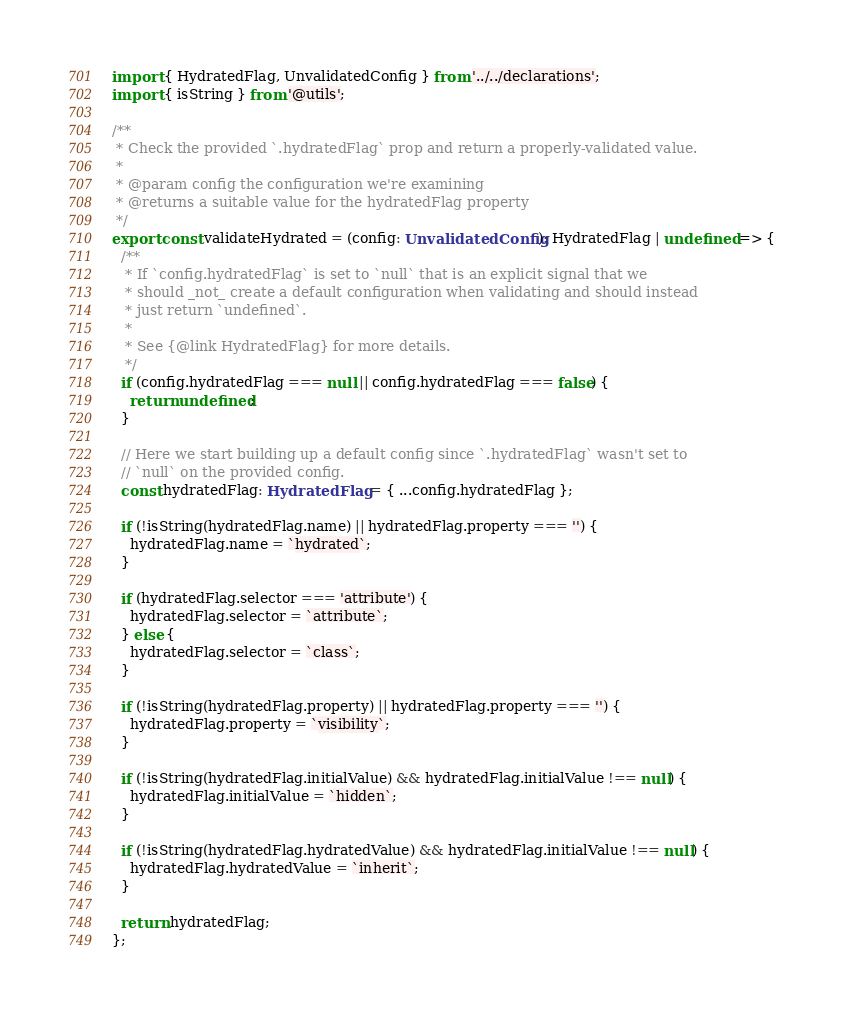<code> <loc_0><loc_0><loc_500><loc_500><_TypeScript_>import { HydratedFlag, UnvalidatedConfig } from '../../declarations';
import { isString } from '@utils';

/**
 * Check the provided `.hydratedFlag` prop and return a properly-validated value.
 *
 * @param config the configuration we're examining
 * @returns a suitable value for the hydratedFlag property
 */
export const validateHydrated = (config: UnvalidatedConfig): HydratedFlag | undefined => {
  /**
   * If `config.hydratedFlag` is set to `null` that is an explicit signal that we
   * should _not_ create a default configuration when validating and should instead
   * just return `undefined`.
   *
   * See {@link HydratedFlag} for more details.
   */
  if (config.hydratedFlag === null || config.hydratedFlag === false) {
    return undefined;
  }

  // Here we start building up a default config since `.hydratedFlag` wasn't set to
  // `null` on the provided config.
  const hydratedFlag: HydratedFlag = { ...config.hydratedFlag };

  if (!isString(hydratedFlag.name) || hydratedFlag.property === '') {
    hydratedFlag.name = `hydrated`;
  }

  if (hydratedFlag.selector === 'attribute') {
    hydratedFlag.selector = `attribute`;
  } else {
    hydratedFlag.selector = `class`;
  }

  if (!isString(hydratedFlag.property) || hydratedFlag.property === '') {
    hydratedFlag.property = `visibility`;
  }

  if (!isString(hydratedFlag.initialValue) && hydratedFlag.initialValue !== null) {
    hydratedFlag.initialValue = `hidden`;
  }

  if (!isString(hydratedFlag.hydratedValue) && hydratedFlag.initialValue !== null) {
    hydratedFlag.hydratedValue = `inherit`;
  }

  return hydratedFlag;
};
</code> 